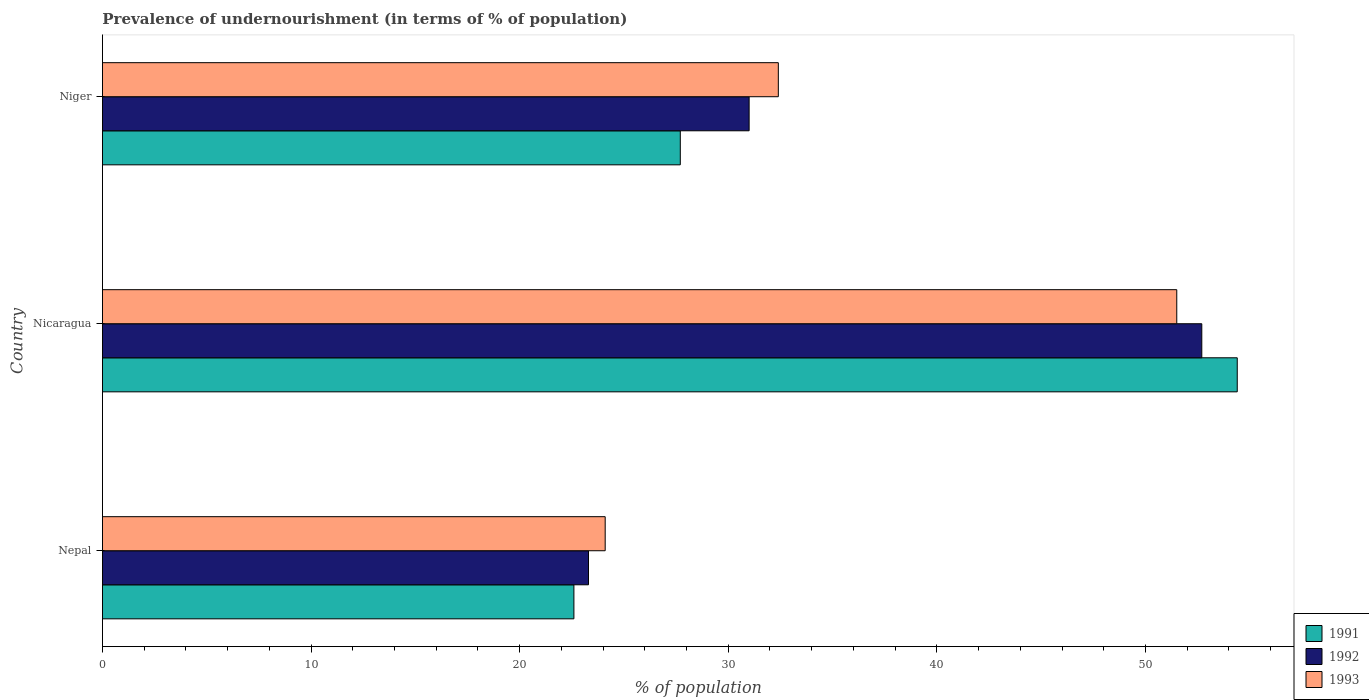How many different coloured bars are there?
Give a very brief answer. 3. How many groups of bars are there?
Offer a terse response. 3. Are the number of bars on each tick of the Y-axis equal?
Your answer should be compact. Yes. What is the label of the 1st group of bars from the top?
Ensure brevity in your answer.  Niger. What is the percentage of undernourished population in 1992 in Nepal?
Your answer should be very brief. 23.3. Across all countries, what is the maximum percentage of undernourished population in 1992?
Make the answer very short. 52.7. Across all countries, what is the minimum percentage of undernourished population in 1993?
Provide a short and direct response. 24.1. In which country was the percentage of undernourished population in 1991 maximum?
Keep it short and to the point. Nicaragua. In which country was the percentage of undernourished population in 1992 minimum?
Your answer should be compact. Nepal. What is the total percentage of undernourished population in 1991 in the graph?
Provide a succinct answer. 104.7. What is the difference between the percentage of undernourished population in 1991 in Nepal and that in Nicaragua?
Offer a very short reply. -31.8. What is the difference between the percentage of undernourished population in 1992 in Nicaragua and the percentage of undernourished population in 1991 in Niger?
Give a very brief answer. 25. What is the average percentage of undernourished population in 1992 per country?
Offer a terse response. 35.67. What is the difference between the percentage of undernourished population in 1992 and percentage of undernourished population in 1993 in Niger?
Provide a short and direct response. -1.4. What is the ratio of the percentage of undernourished population in 1992 in Nicaragua to that in Niger?
Make the answer very short. 1.7. Is the percentage of undernourished population in 1992 in Nepal less than that in Niger?
Offer a terse response. Yes. Is the difference between the percentage of undernourished population in 1992 in Nepal and Nicaragua greater than the difference between the percentage of undernourished population in 1993 in Nepal and Nicaragua?
Ensure brevity in your answer.  No. What is the difference between the highest and the second highest percentage of undernourished population in 1991?
Keep it short and to the point. 26.7. What is the difference between the highest and the lowest percentage of undernourished population in 1991?
Keep it short and to the point. 31.8. Is the sum of the percentage of undernourished population in 1993 in Nicaragua and Niger greater than the maximum percentage of undernourished population in 1991 across all countries?
Your response must be concise. Yes. What does the 2nd bar from the bottom in Niger represents?
Provide a succinct answer. 1992. Is it the case that in every country, the sum of the percentage of undernourished population in 1992 and percentage of undernourished population in 1993 is greater than the percentage of undernourished population in 1991?
Ensure brevity in your answer.  Yes. Are the values on the major ticks of X-axis written in scientific E-notation?
Offer a very short reply. No. How many legend labels are there?
Offer a very short reply. 3. How are the legend labels stacked?
Provide a succinct answer. Vertical. What is the title of the graph?
Ensure brevity in your answer.  Prevalence of undernourishment (in terms of % of population). What is the label or title of the X-axis?
Your response must be concise. % of population. What is the label or title of the Y-axis?
Offer a terse response. Country. What is the % of population in 1991 in Nepal?
Offer a terse response. 22.6. What is the % of population of 1992 in Nepal?
Your response must be concise. 23.3. What is the % of population in 1993 in Nepal?
Your answer should be compact. 24.1. What is the % of population in 1991 in Nicaragua?
Give a very brief answer. 54.4. What is the % of population in 1992 in Nicaragua?
Offer a very short reply. 52.7. What is the % of population in 1993 in Nicaragua?
Your answer should be compact. 51.5. What is the % of population in 1991 in Niger?
Provide a succinct answer. 27.7. What is the % of population in 1993 in Niger?
Ensure brevity in your answer.  32.4. Across all countries, what is the maximum % of population of 1991?
Make the answer very short. 54.4. Across all countries, what is the maximum % of population of 1992?
Offer a terse response. 52.7. Across all countries, what is the maximum % of population in 1993?
Offer a terse response. 51.5. Across all countries, what is the minimum % of population in 1991?
Keep it short and to the point. 22.6. Across all countries, what is the minimum % of population in 1992?
Offer a terse response. 23.3. Across all countries, what is the minimum % of population of 1993?
Make the answer very short. 24.1. What is the total % of population in 1991 in the graph?
Ensure brevity in your answer.  104.7. What is the total % of population of 1992 in the graph?
Offer a very short reply. 107. What is the total % of population of 1993 in the graph?
Give a very brief answer. 108. What is the difference between the % of population in 1991 in Nepal and that in Nicaragua?
Your answer should be very brief. -31.8. What is the difference between the % of population in 1992 in Nepal and that in Nicaragua?
Offer a terse response. -29.4. What is the difference between the % of population of 1993 in Nepal and that in Nicaragua?
Your answer should be compact. -27.4. What is the difference between the % of population in 1991 in Nepal and that in Niger?
Your response must be concise. -5.1. What is the difference between the % of population of 1992 in Nepal and that in Niger?
Make the answer very short. -7.7. What is the difference between the % of population of 1993 in Nepal and that in Niger?
Provide a succinct answer. -8.3. What is the difference between the % of population in 1991 in Nicaragua and that in Niger?
Ensure brevity in your answer.  26.7. What is the difference between the % of population in 1992 in Nicaragua and that in Niger?
Your answer should be compact. 21.7. What is the difference between the % of population of 1993 in Nicaragua and that in Niger?
Provide a short and direct response. 19.1. What is the difference between the % of population of 1991 in Nepal and the % of population of 1992 in Nicaragua?
Provide a short and direct response. -30.1. What is the difference between the % of population of 1991 in Nepal and the % of population of 1993 in Nicaragua?
Make the answer very short. -28.9. What is the difference between the % of population of 1992 in Nepal and the % of population of 1993 in Nicaragua?
Your response must be concise. -28.2. What is the difference between the % of population of 1991 in Nepal and the % of population of 1992 in Niger?
Your response must be concise. -8.4. What is the difference between the % of population in 1991 in Nepal and the % of population in 1993 in Niger?
Your answer should be compact. -9.8. What is the difference between the % of population of 1991 in Nicaragua and the % of population of 1992 in Niger?
Give a very brief answer. 23.4. What is the difference between the % of population of 1992 in Nicaragua and the % of population of 1993 in Niger?
Give a very brief answer. 20.3. What is the average % of population of 1991 per country?
Ensure brevity in your answer.  34.9. What is the average % of population in 1992 per country?
Provide a succinct answer. 35.67. What is the average % of population of 1993 per country?
Provide a succinct answer. 36. What is the difference between the % of population in 1991 and % of population in 1993 in Nepal?
Give a very brief answer. -1.5. What is the difference between the % of population in 1991 and % of population in 1992 in Nicaragua?
Ensure brevity in your answer.  1.7. What is the difference between the % of population of 1991 and % of population of 1993 in Nicaragua?
Your response must be concise. 2.9. What is the difference between the % of population of 1992 and % of population of 1993 in Nicaragua?
Provide a short and direct response. 1.2. What is the difference between the % of population in 1991 and % of population in 1992 in Niger?
Offer a terse response. -3.3. What is the difference between the % of population in 1992 and % of population in 1993 in Niger?
Offer a very short reply. -1.4. What is the ratio of the % of population in 1991 in Nepal to that in Nicaragua?
Keep it short and to the point. 0.42. What is the ratio of the % of population in 1992 in Nepal to that in Nicaragua?
Your answer should be very brief. 0.44. What is the ratio of the % of population of 1993 in Nepal to that in Nicaragua?
Offer a very short reply. 0.47. What is the ratio of the % of population of 1991 in Nepal to that in Niger?
Keep it short and to the point. 0.82. What is the ratio of the % of population in 1992 in Nepal to that in Niger?
Provide a short and direct response. 0.75. What is the ratio of the % of population in 1993 in Nepal to that in Niger?
Keep it short and to the point. 0.74. What is the ratio of the % of population in 1991 in Nicaragua to that in Niger?
Make the answer very short. 1.96. What is the ratio of the % of population of 1992 in Nicaragua to that in Niger?
Offer a terse response. 1.7. What is the ratio of the % of population of 1993 in Nicaragua to that in Niger?
Your answer should be very brief. 1.59. What is the difference between the highest and the second highest % of population of 1991?
Your answer should be compact. 26.7. What is the difference between the highest and the second highest % of population of 1992?
Offer a very short reply. 21.7. What is the difference between the highest and the lowest % of population in 1991?
Offer a terse response. 31.8. What is the difference between the highest and the lowest % of population in 1992?
Your answer should be very brief. 29.4. What is the difference between the highest and the lowest % of population in 1993?
Offer a terse response. 27.4. 